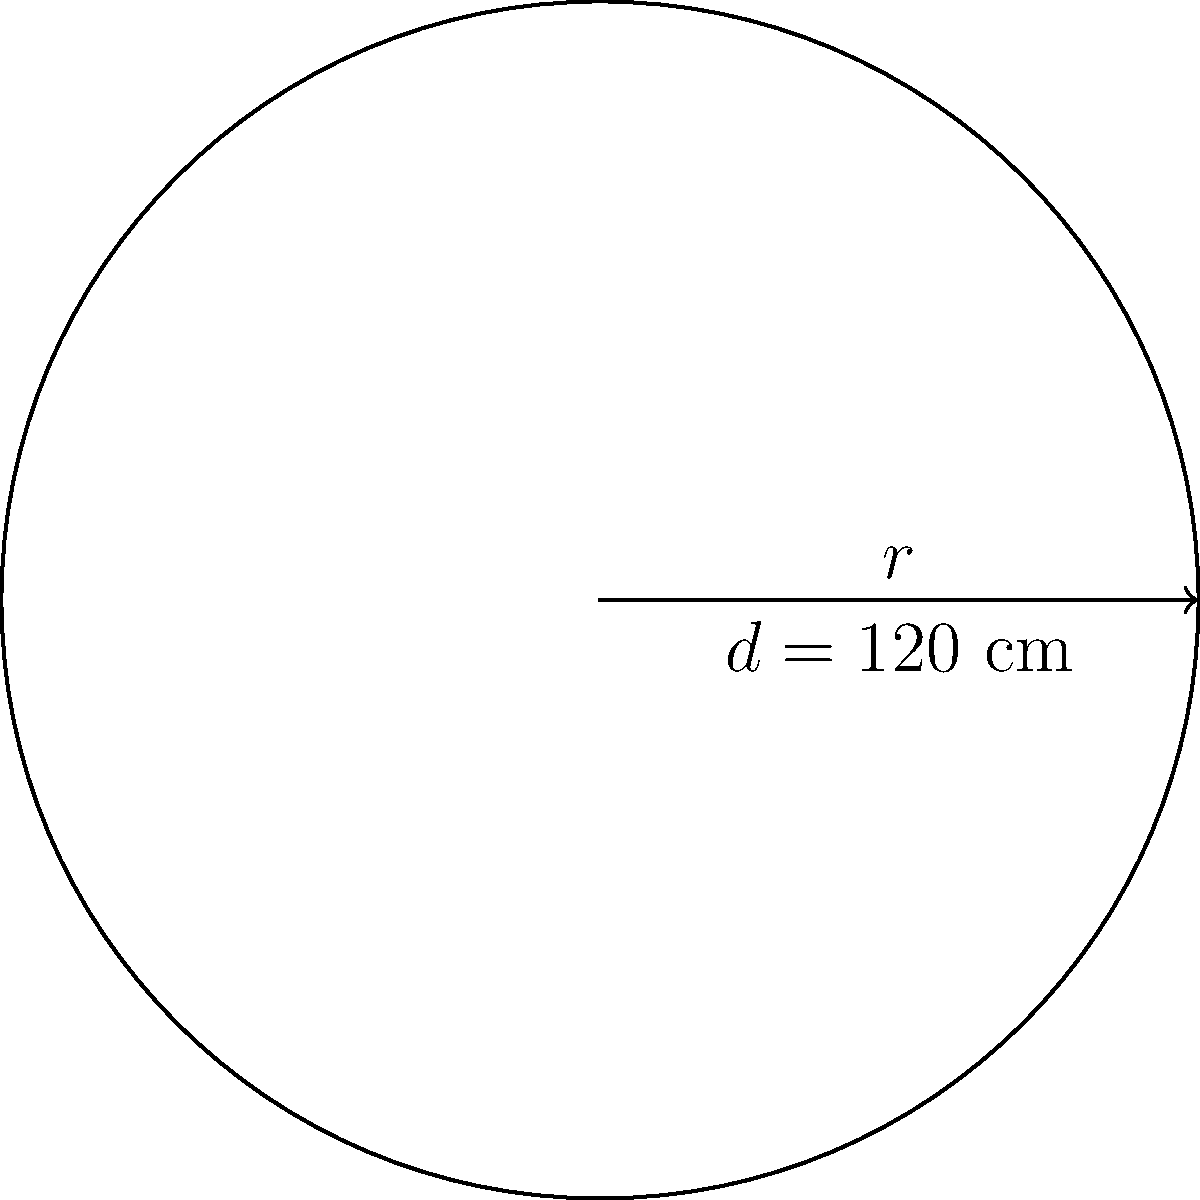You are designing a circular table top for a custom order. The customer has requested a diameter of 120 cm. Calculate the circumference of the table top to determine the amount of edge banding material needed. To solve this problem, we'll follow these steps:

1. Recall the formula for the circumference of a circle:
   $$C = \pi d$$
   where $C$ is the circumference, $\pi$ is pi (approximately 3.14159), and $d$ is the diameter.

2. We are given the diameter $d = 120$ cm.

3. Substitute the values into the formula:
   $$C = \pi \times 120$$

4. Calculate:
   $$C \approx 3.14159 \times 120 \approx 376.99$ cm$$

5. Round to two decimal places for practical use:
   $$C \approx 377.00$ cm$$

Therefore, you will need approximately 377.00 cm of edge banding material for the circular table top.
Answer: $377.00$ cm 